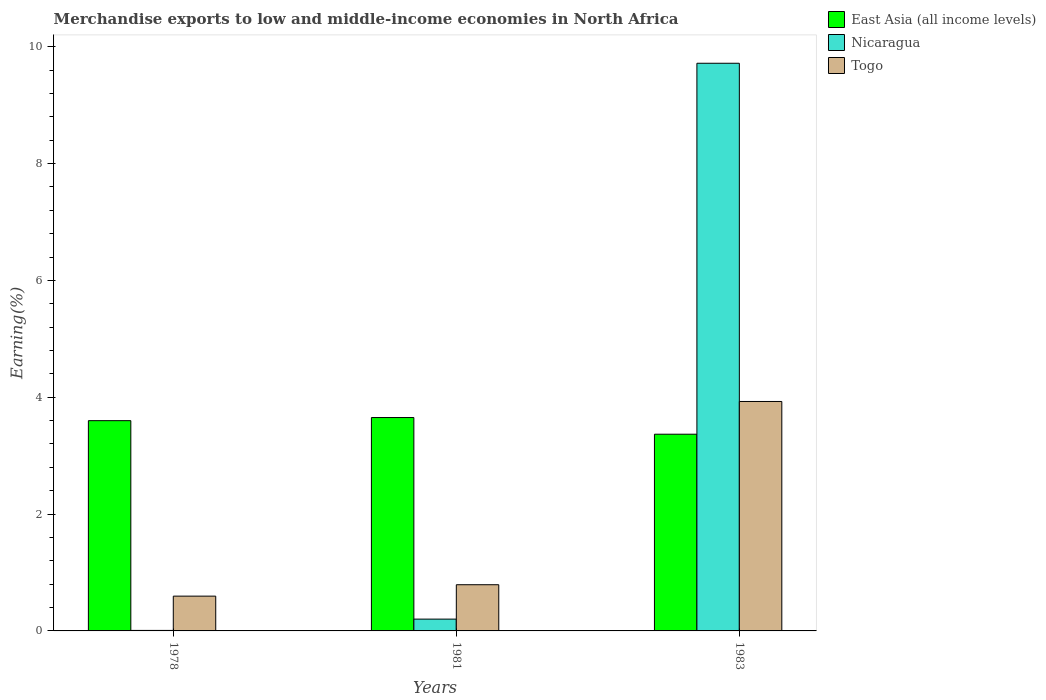How many bars are there on the 1st tick from the left?
Your response must be concise. 3. What is the percentage of amount earned from merchandise exports in East Asia (all income levels) in 1978?
Your response must be concise. 3.6. Across all years, what is the maximum percentage of amount earned from merchandise exports in Togo?
Make the answer very short. 3.93. Across all years, what is the minimum percentage of amount earned from merchandise exports in Nicaragua?
Provide a succinct answer. 0.01. In which year was the percentage of amount earned from merchandise exports in Togo minimum?
Your answer should be very brief. 1978. What is the total percentage of amount earned from merchandise exports in Togo in the graph?
Ensure brevity in your answer.  5.31. What is the difference between the percentage of amount earned from merchandise exports in Togo in 1978 and that in 1981?
Provide a succinct answer. -0.2. What is the difference between the percentage of amount earned from merchandise exports in Nicaragua in 1981 and the percentage of amount earned from merchandise exports in Togo in 1983?
Provide a short and direct response. -3.73. What is the average percentage of amount earned from merchandise exports in East Asia (all income levels) per year?
Ensure brevity in your answer.  3.54. In the year 1978, what is the difference between the percentage of amount earned from merchandise exports in Togo and percentage of amount earned from merchandise exports in Nicaragua?
Offer a very short reply. 0.59. In how many years, is the percentage of amount earned from merchandise exports in Nicaragua greater than 8.4 %?
Make the answer very short. 1. What is the ratio of the percentage of amount earned from merchandise exports in East Asia (all income levels) in 1981 to that in 1983?
Offer a very short reply. 1.08. What is the difference between the highest and the second highest percentage of amount earned from merchandise exports in Nicaragua?
Offer a very short reply. 9.51. What is the difference between the highest and the lowest percentage of amount earned from merchandise exports in Nicaragua?
Provide a succinct answer. 9.71. In how many years, is the percentage of amount earned from merchandise exports in East Asia (all income levels) greater than the average percentage of amount earned from merchandise exports in East Asia (all income levels) taken over all years?
Make the answer very short. 2. Is the sum of the percentage of amount earned from merchandise exports in Togo in 1981 and 1983 greater than the maximum percentage of amount earned from merchandise exports in Nicaragua across all years?
Keep it short and to the point. No. What does the 1st bar from the left in 1983 represents?
Give a very brief answer. East Asia (all income levels). What does the 2nd bar from the right in 1981 represents?
Your response must be concise. Nicaragua. How many bars are there?
Provide a succinct answer. 9. How many years are there in the graph?
Offer a terse response. 3. What is the difference between two consecutive major ticks on the Y-axis?
Offer a terse response. 2. Are the values on the major ticks of Y-axis written in scientific E-notation?
Offer a very short reply. No. Where does the legend appear in the graph?
Provide a succinct answer. Top right. How many legend labels are there?
Give a very brief answer. 3. How are the legend labels stacked?
Your answer should be very brief. Vertical. What is the title of the graph?
Provide a succinct answer. Merchandise exports to low and middle-income economies in North Africa. What is the label or title of the Y-axis?
Keep it short and to the point. Earning(%). What is the Earning(%) in East Asia (all income levels) in 1978?
Your answer should be very brief. 3.6. What is the Earning(%) of Nicaragua in 1978?
Offer a very short reply. 0.01. What is the Earning(%) in Togo in 1978?
Make the answer very short. 0.6. What is the Earning(%) in East Asia (all income levels) in 1981?
Ensure brevity in your answer.  3.65. What is the Earning(%) of Nicaragua in 1981?
Your answer should be compact. 0.2. What is the Earning(%) in Togo in 1981?
Provide a succinct answer. 0.79. What is the Earning(%) of East Asia (all income levels) in 1983?
Make the answer very short. 3.37. What is the Earning(%) of Nicaragua in 1983?
Offer a terse response. 9.72. What is the Earning(%) of Togo in 1983?
Offer a terse response. 3.93. Across all years, what is the maximum Earning(%) of East Asia (all income levels)?
Give a very brief answer. 3.65. Across all years, what is the maximum Earning(%) of Nicaragua?
Provide a short and direct response. 9.72. Across all years, what is the maximum Earning(%) of Togo?
Ensure brevity in your answer.  3.93. Across all years, what is the minimum Earning(%) of East Asia (all income levels)?
Offer a terse response. 3.37. Across all years, what is the minimum Earning(%) in Nicaragua?
Provide a short and direct response. 0.01. Across all years, what is the minimum Earning(%) of Togo?
Your answer should be compact. 0.6. What is the total Earning(%) in East Asia (all income levels) in the graph?
Offer a very short reply. 10.62. What is the total Earning(%) in Nicaragua in the graph?
Offer a very short reply. 9.93. What is the total Earning(%) in Togo in the graph?
Make the answer very short. 5.31. What is the difference between the Earning(%) in East Asia (all income levels) in 1978 and that in 1981?
Give a very brief answer. -0.05. What is the difference between the Earning(%) of Nicaragua in 1978 and that in 1981?
Offer a very short reply. -0.19. What is the difference between the Earning(%) of Togo in 1978 and that in 1981?
Keep it short and to the point. -0.2. What is the difference between the Earning(%) of East Asia (all income levels) in 1978 and that in 1983?
Provide a short and direct response. 0.23. What is the difference between the Earning(%) of Nicaragua in 1978 and that in 1983?
Keep it short and to the point. -9.71. What is the difference between the Earning(%) of Togo in 1978 and that in 1983?
Ensure brevity in your answer.  -3.33. What is the difference between the Earning(%) of East Asia (all income levels) in 1981 and that in 1983?
Provide a short and direct response. 0.29. What is the difference between the Earning(%) of Nicaragua in 1981 and that in 1983?
Keep it short and to the point. -9.51. What is the difference between the Earning(%) of Togo in 1981 and that in 1983?
Keep it short and to the point. -3.14. What is the difference between the Earning(%) in East Asia (all income levels) in 1978 and the Earning(%) in Nicaragua in 1981?
Offer a terse response. 3.4. What is the difference between the Earning(%) of East Asia (all income levels) in 1978 and the Earning(%) of Togo in 1981?
Give a very brief answer. 2.81. What is the difference between the Earning(%) of Nicaragua in 1978 and the Earning(%) of Togo in 1981?
Ensure brevity in your answer.  -0.78. What is the difference between the Earning(%) in East Asia (all income levels) in 1978 and the Earning(%) in Nicaragua in 1983?
Your answer should be compact. -6.12. What is the difference between the Earning(%) of East Asia (all income levels) in 1978 and the Earning(%) of Togo in 1983?
Your answer should be very brief. -0.33. What is the difference between the Earning(%) of Nicaragua in 1978 and the Earning(%) of Togo in 1983?
Offer a terse response. -3.92. What is the difference between the Earning(%) of East Asia (all income levels) in 1981 and the Earning(%) of Nicaragua in 1983?
Your answer should be very brief. -6.06. What is the difference between the Earning(%) in East Asia (all income levels) in 1981 and the Earning(%) in Togo in 1983?
Offer a terse response. -0.28. What is the difference between the Earning(%) in Nicaragua in 1981 and the Earning(%) in Togo in 1983?
Your answer should be compact. -3.73. What is the average Earning(%) of East Asia (all income levels) per year?
Make the answer very short. 3.54. What is the average Earning(%) of Nicaragua per year?
Your answer should be very brief. 3.31. What is the average Earning(%) of Togo per year?
Provide a succinct answer. 1.77. In the year 1978, what is the difference between the Earning(%) in East Asia (all income levels) and Earning(%) in Nicaragua?
Your answer should be very brief. 3.59. In the year 1978, what is the difference between the Earning(%) in East Asia (all income levels) and Earning(%) in Togo?
Your answer should be very brief. 3. In the year 1978, what is the difference between the Earning(%) in Nicaragua and Earning(%) in Togo?
Give a very brief answer. -0.59. In the year 1981, what is the difference between the Earning(%) of East Asia (all income levels) and Earning(%) of Nicaragua?
Ensure brevity in your answer.  3.45. In the year 1981, what is the difference between the Earning(%) in East Asia (all income levels) and Earning(%) in Togo?
Make the answer very short. 2.86. In the year 1981, what is the difference between the Earning(%) in Nicaragua and Earning(%) in Togo?
Offer a terse response. -0.59. In the year 1983, what is the difference between the Earning(%) in East Asia (all income levels) and Earning(%) in Nicaragua?
Keep it short and to the point. -6.35. In the year 1983, what is the difference between the Earning(%) in East Asia (all income levels) and Earning(%) in Togo?
Give a very brief answer. -0.56. In the year 1983, what is the difference between the Earning(%) of Nicaragua and Earning(%) of Togo?
Your answer should be very brief. 5.79. What is the ratio of the Earning(%) of East Asia (all income levels) in 1978 to that in 1981?
Keep it short and to the point. 0.99. What is the ratio of the Earning(%) in Nicaragua in 1978 to that in 1981?
Your answer should be compact. 0.04. What is the ratio of the Earning(%) of Togo in 1978 to that in 1981?
Your answer should be very brief. 0.75. What is the ratio of the Earning(%) of East Asia (all income levels) in 1978 to that in 1983?
Your answer should be compact. 1.07. What is the ratio of the Earning(%) of Nicaragua in 1978 to that in 1983?
Provide a short and direct response. 0. What is the ratio of the Earning(%) of Togo in 1978 to that in 1983?
Provide a succinct answer. 0.15. What is the ratio of the Earning(%) of East Asia (all income levels) in 1981 to that in 1983?
Your answer should be compact. 1.08. What is the ratio of the Earning(%) of Nicaragua in 1981 to that in 1983?
Provide a short and direct response. 0.02. What is the ratio of the Earning(%) in Togo in 1981 to that in 1983?
Offer a very short reply. 0.2. What is the difference between the highest and the second highest Earning(%) in East Asia (all income levels)?
Provide a short and direct response. 0.05. What is the difference between the highest and the second highest Earning(%) of Nicaragua?
Give a very brief answer. 9.51. What is the difference between the highest and the second highest Earning(%) of Togo?
Your response must be concise. 3.14. What is the difference between the highest and the lowest Earning(%) in East Asia (all income levels)?
Your answer should be very brief. 0.29. What is the difference between the highest and the lowest Earning(%) of Nicaragua?
Give a very brief answer. 9.71. What is the difference between the highest and the lowest Earning(%) of Togo?
Your answer should be very brief. 3.33. 